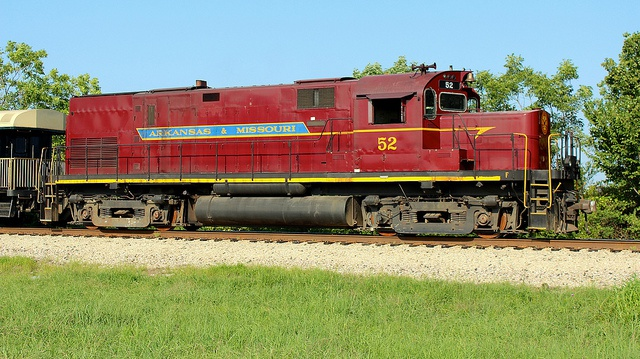Describe the objects in this image and their specific colors. I can see a train in lightblue, black, brown, and gray tones in this image. 